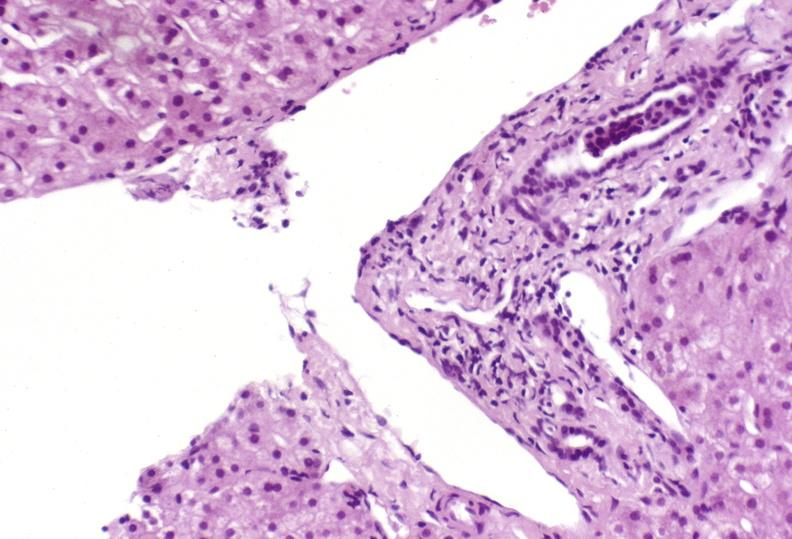s liver present?
Answer the question using a single word or phrase. Yes 